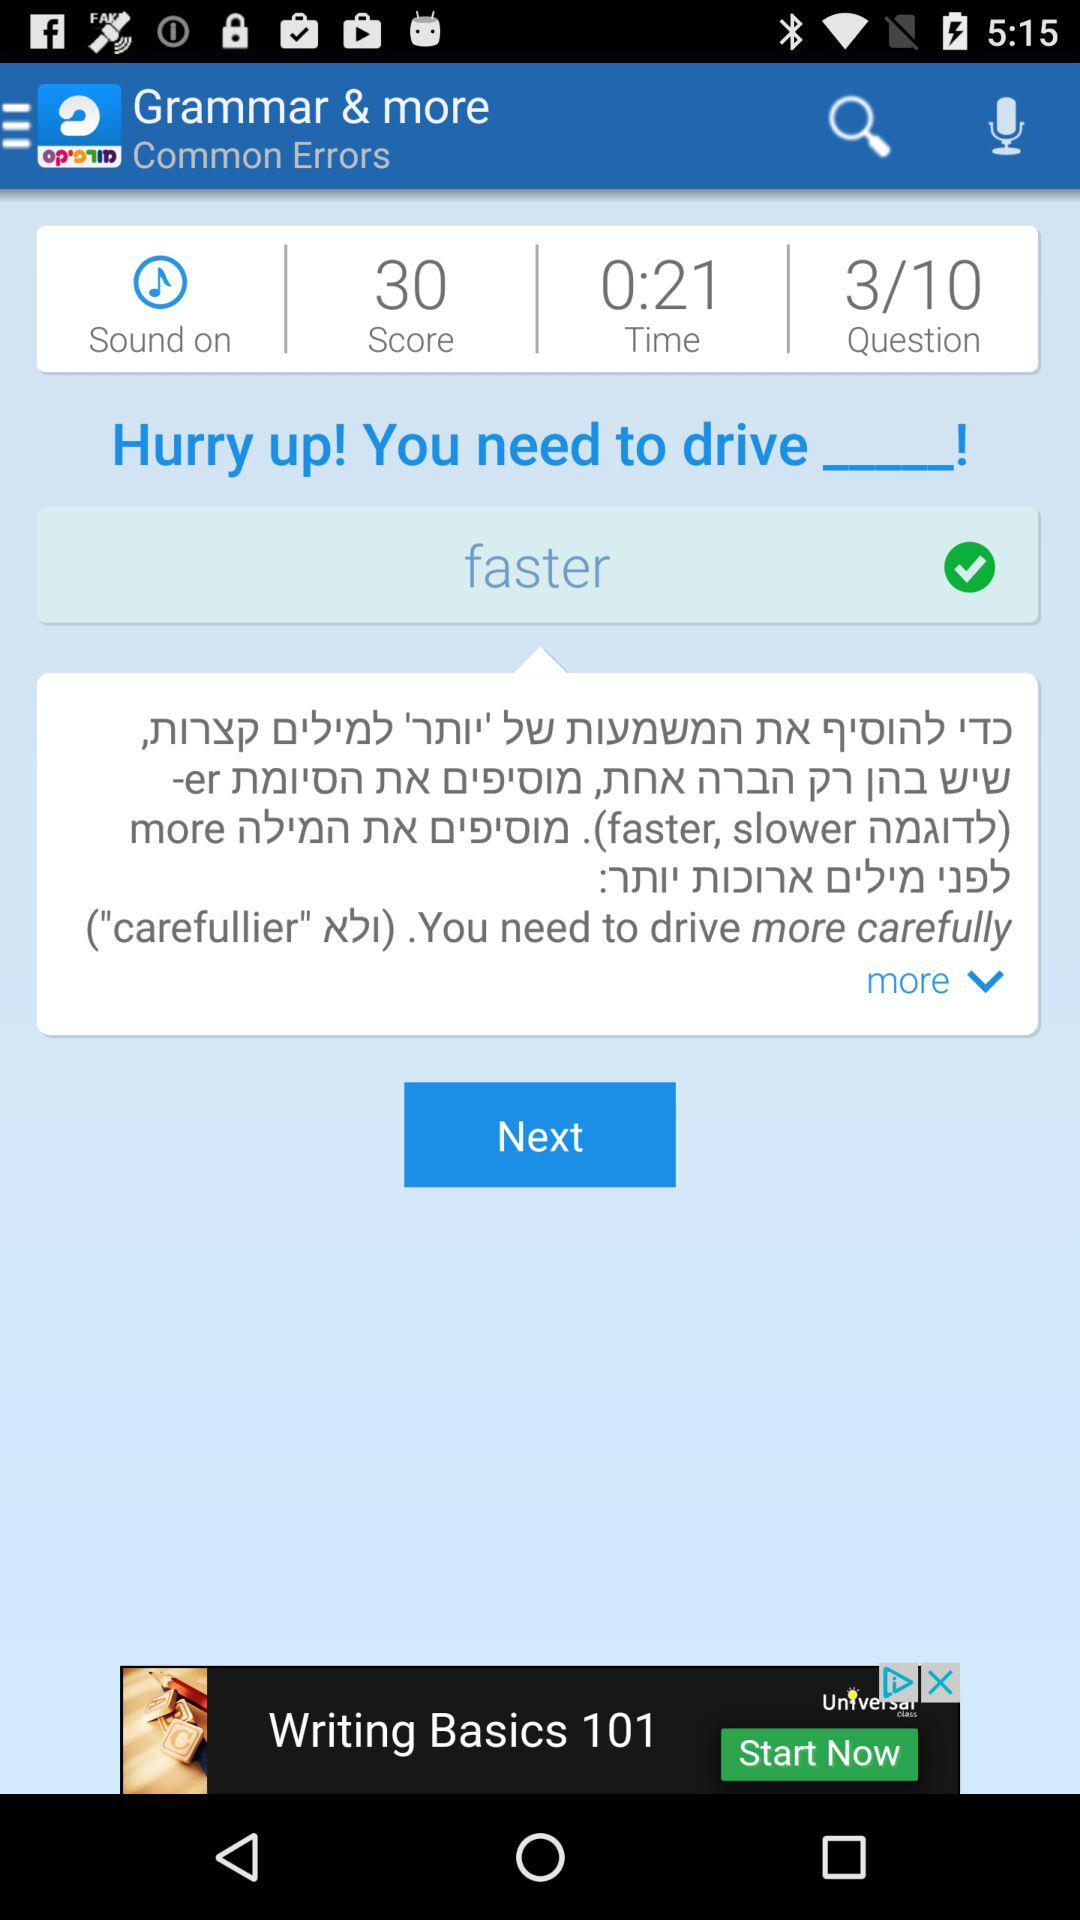What is the total number of questions asked in the test? The total number of questions is 10. 